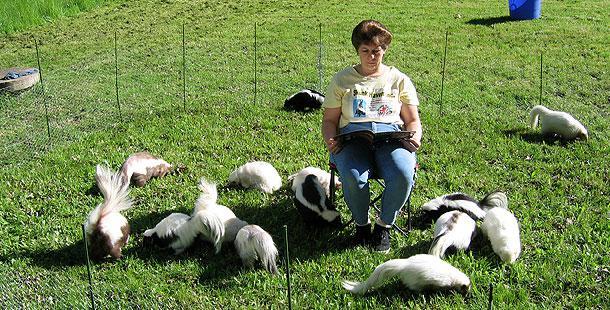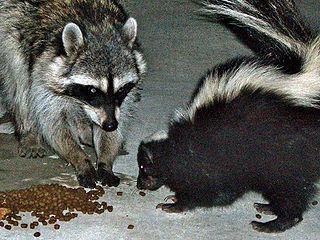The first image is the image on the left, the second image is the image on the right. Analyze the images presented: Is the assertion "At least one skunk is eating." valid? Answer yes or no. Yes. 